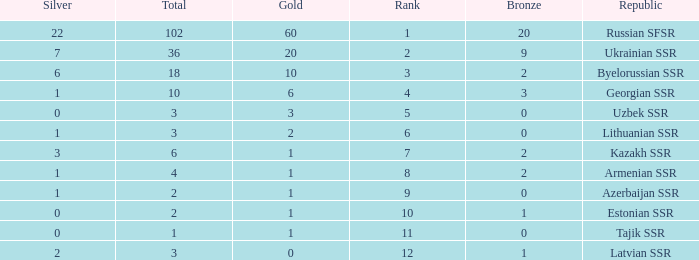What is the total number of bronzes associated with 1 silver, ranks under 6 and under 6 golds? None. 